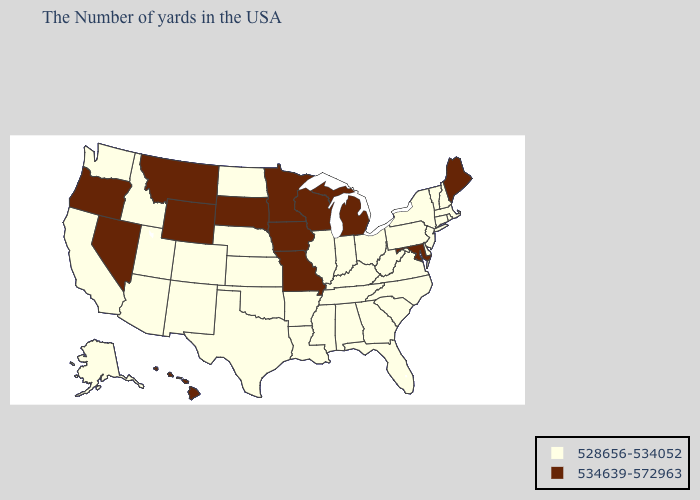Does the map have missing data?
Write a very short answer. No. Name the states that have a value in the range 534639-572963?
Write a very short answer. Maine, Maryland, Michigan, Wisconsin, Missouri, Minnesota, Iowa, South Dakota, Wyoming, Montana, Nevada, Oregon, Hawaii. Does the first symbol in the legend represent the smallest category?
Short answer required. Yes. Name the states that have a value in the range 534639-572963?
Concise answer only. Maine, Maryland, Michigan, Wisconsin, Missouri, Minnesota, Iowa, South Dakota, Wyoming, Montana, Nevada, Oregon, Hawaii. Name the states that have a value in the range 528656-534052?
Concise answer only. Massachusetts, Rhode Island, New Hampshire, Vermont, Connecticut, New York, New Jersey, Delaware, Pennsylvania, Virginia, North Carolina, South Carolina, West Virginia, Ohio, Florida, Georgia, Kentucky, Indiana, Alabama, Tennessee, Illinois, Mississippi, Louisiana, Arkansas, Kansas, Nebraska, Oklahoma, Texas, North Dakota, Colorado, New Mexico, Utah, Arizona, Idaho, California, Washington, Alaska. Is the legend a continuous bar?
Quick response, please. No. What is the lowest value in the MidWest?
Short answer required. 528656-534052. Name the states that have a value in the range 534639-572963?
Give a very brief answer. Maine, Maryland, Michigan, Wisconsin, Missouri, Minnesota, Iowa, South Dakota, Wyoming, Montana, Nevada, Oregon, Hawaii. What is the lowest value in states that border Iowa?
Keep it brief. 528656-534052. Which states hav the highest value in the Northeast?
Keep it brief. Maine. What is the value of New York?
Answer briefly. 528656-534052. What is the value of Connecticut?
Keep it brief. 528656-534052. What is the lowest value in states that border Kansas?
Give a very brief answer. 528656-534052. Does New Mexico have a higher value than New Jersey?
Quick response, please. No. Does Vermont have the lowest value in the USA?
Give a very brief answer. Yes. 